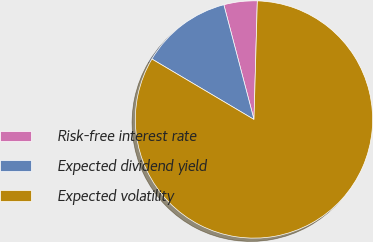Convert chart to OTSL. <chart><loc_0><loc_0><loc_500><loc_500><pie_chart><fcel>Risk-free interest rate<fcel>Expected dividend yield<fcel>Expected volatility<nl><fcel>4.54%<fcel>12.4%<fcel>83.07%<nl></chart> 